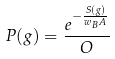<formula> <loc_0><loc_0><loc_500><loc_500>P ( g ) = \frac { e ^ { - \frac { S ( g ) } { w _ { B } A } } } { O }</formula> 